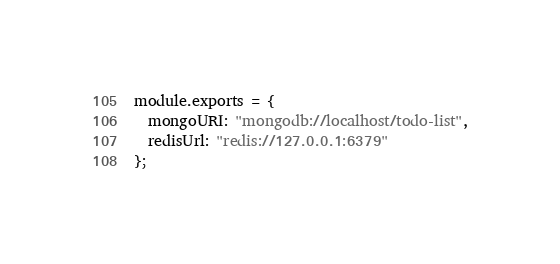Convert code to text. <code><loc_0><loc_0><loc_500><loc_500><_JavaScript_>module.exports = {
  mongoURI: "mongodb://localhost/todo-list",
  redisUrl: "redis://127.0.0.1:6379"
};
</code> 